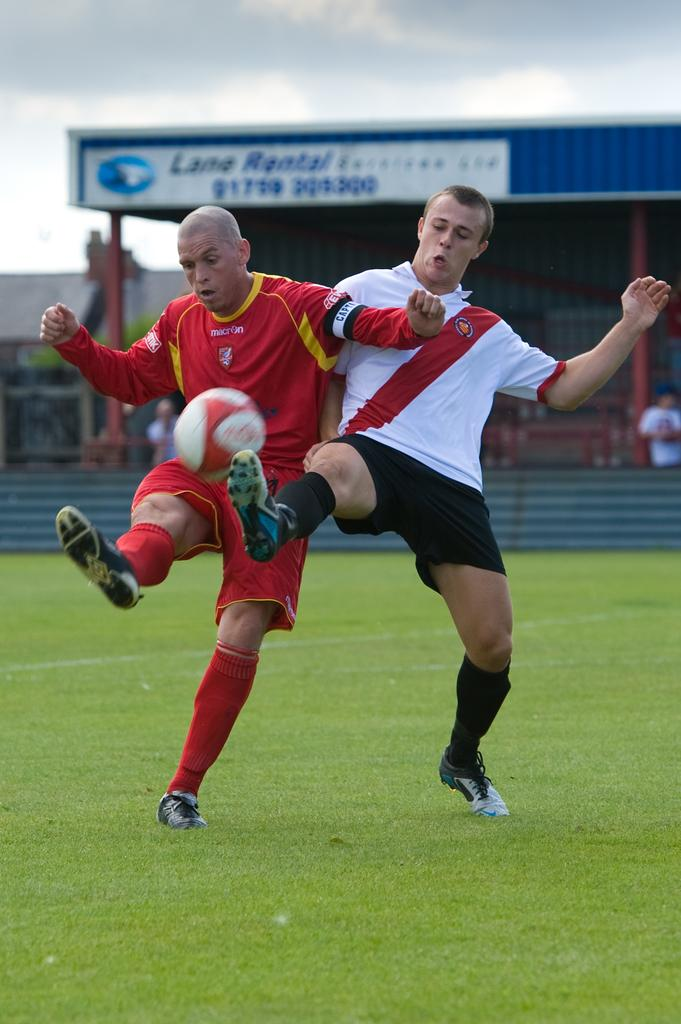What are the two persons in the image doing? The two persons in the image are playing football. Where is the football game taking place? The football game is taking place on a ground. What can be seen in the background of the image? In the background of the image, there are sheds, poles, a board, people, and the sky with clouds. How many eyes does the pig have in the image? There is no pig present in the image, so it is not possible to determine the number of eyes it might have. 